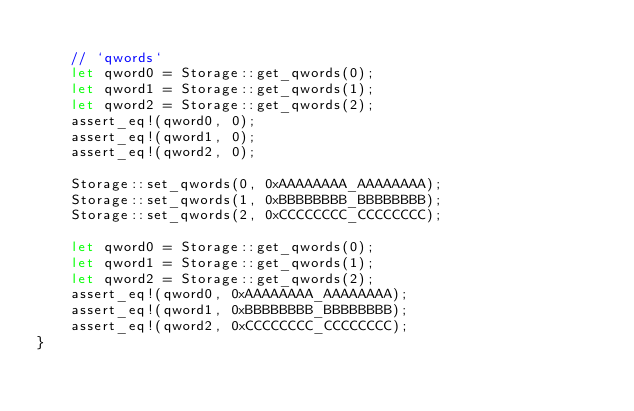Convert code to text. <code><loc_0><loc_0><loc_500><loc_500><_Rust_>
    // `qwords`
    let qword0 = Storage::get_qwords(0);
    let qword1 = Storage::get_qwords(1);
    let qword2 = Storage::get_qwords(2);
    assert_eq!(qword0, 0);
    assert_eq!(qword1, 0);
    assert_eq!(qword2, 0);

    Storage::set_qwords(0, 0xAAAAAAAA_AAAAAAAA);
    Storage::set_qwords(1, 0xBBBBBBBB_BBBBBBBB);
    Storage::set_qwords(2, 0xCCCCCCCC_CCCCCCCC);

    let qword0 = Storage::get_qwords(0);
    let qword1 = Storage::get_qwords(1);
    let qword2 = Storage::get_qwords(2);
    assert_eq!(qword0, 0xAAAAAAAA_AAAAAAAA);
    assert_eq!(qword1, 0xBBBBBBBB_BBBBBBBB);
    assert_eq!(qword2, 0xCCCCCCCC_CCCCCCCC);
}
</code> 